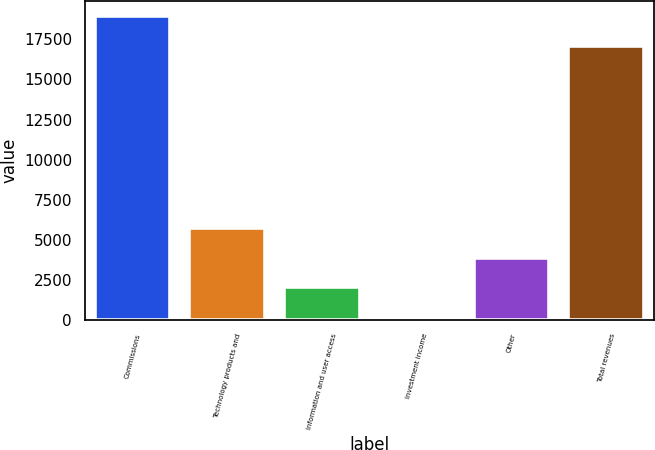<chart> <loc_0><loc_0><loc_500><loc_500><bar_chart><fcel>Commissions<fcel>Technology products and<fcel>Information and user access<fcel>Investment income<fcel>Other<fcel>Total revenues<nl><fcel>18963.4<fcel>5746.2<fcel>2029.4<fcel>171<fcel>3887.8<fcel>17105<nl></chart> 